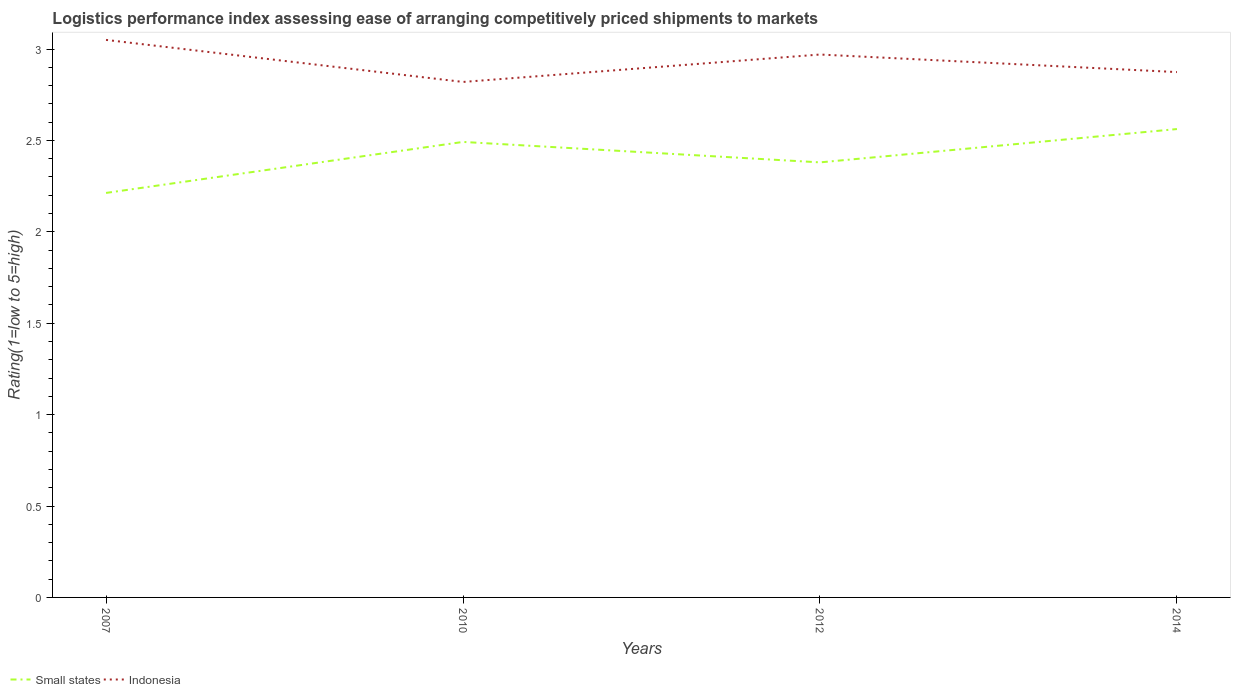How many different coloured lines are there?
Provide a succinct answer. 2. Does the line corresponding to Small states intersect with the line corresponding to Indonesia?
Keep it short and to the point. No. Is the number of lines equal to the number of legend labels?
Offer a very short reply. Yes. Across all years, what is the maximum Logistic performance index in Indonesia?
Keep it short and to the point. 2.82. In which year was the Logistic performance index in Indonesia maximum?
Give a very brief answer. 2010. What is the total Logistic performance index in Small states in the graph?
Make the answer very short. -0.28. What is the difference between the highest and the second highest Logistic performance index in Small states?
Your response must be concise. 0.35. What is the difference between two consecutive major ticks on the Y-axis?
Provide a short and direct response. 0.5. Are the values on the major ticks of Y-axis written in scientific E-notation?
Keep it short and to the point. No. What is the title of the graph?
Offer a very short reply. Logistics performance index assessing ease of arranging competitively priced shipments to markets. What is the label or title of the X-axis?
Offer a terse response. Years. What is the label or title of the Y-axis?
Offer a terse response. Rating(1=low to 5=high). What is the Rating(1=low to 5=high) of Small states in 2007?
Your answer should be very brief. 2.21. What is the Rating(1=low to 5=high) of Indonesia in 2007?
Offer a very short reply. 3.05. What is the Rating(1=low to 5=high) in Small states in 2010?
Your answer should be compact. 2.49. What is the Rating(1=low to 5=high) of Indonesia in 2010?
Offer a very short reply. 2.82. What is the Rating(1=low to 5=high) of Small states in 2012?
Offer a very short reply. 2.38. What is the Rating(1=low to 5=high) in Indonesia in 2012?
Offer a terse response. 2.97. What is the Rating(1=low to 5=high) in Small states in 2014?
Your response must be concise. 2.56. What is the Rating(1=low to 5=high) of Indonesia in 2014?
Your response must be concise. 2.87. Across all years, what is the maximum Rating(1=low to 5=high) of Small states?
Provide a succinct answer. 2.56. Across all years, what is the maximum Rating(1=low to 5=high) in Indonesia?
Offer a very short reply. 3.05. Across all years, what is the minimum Rating(1=low to 5=high) in Small states?
Ensure brevity in your answer.  2.21. Across all years, what is the minimum Rating(1=low to 5=high) of Indonesia?
Offer a very short reply. 2.82. What is the total Rating(1=low to 5=high) in Small states in the graph?
Provide a succinct answer. 9.65. What is the total Rating(1=low to 5=high) of Indonesia in the graph?
Make the answer very short. 11.71. What is the difference between the Rating(1=low to 5=high) of Small states in 2007 and that in 2010?
Give a very brief answer. -0.28. What is the difference between the Rating(1=low to 5=high) of Indonesia in 2007 and that in 2010?
Ensure brevity in your answer.  0.23. What is the difference between the Rating(1=low to 5=high) of Small states in 2007 and that in 2012?
Make the answer very short. -0.17. What is the difference between the Rating(1=low to 5=high) of Small states in 2007 and that in 2014?
Keep it short and to the point. -0.35. What is the difference between the Rating(1=low to 5=high) in Indonesia in 2007 and that in 2014?
Keep it short and to the point. 0.18. What is the difference between the Rating(1=low to 5=high) in Small states in 2010 and that in 2012?
Ensure brevity in your answer.  0.11. What is the difference between the Rating(1=low to 5=high) of Small states in 2010 and that in 2014?
Ensure brevity in your answer.  -0.07. What is the difference between the Rating(1=low to 5=high) of Indonesia in 2010 and that in 2014?
Your answer should be very brief. -0.05. What is the difference between the Rating(1=low to 5=high) in Small states in 2012 and that in 2014?
Provide a short and direct response. -0.18. What is the difference between the Rating(1=low to 5=high) in Indonesia in 2012 and that in 2014?
Offer a very short reply. 0.1. What is the difference between the Rating(1=low to 5=high) in Small states in 2007 and the Rating(1=low to 5=high) in Indonesia in 2010?
Offer a terse response. -0.61. What is the difference between the Rating(1=low to 5=high) of Small states in 2007 and the Rating(1=low to 5=high) of Indonesia in 2012?
Keep it short and to the point. -0.76. What is the difference between the Rating(1=low to 5=high) of Small states in 2007 and the Rating(1=low to 5=high) of Indonesia in 2014?
Your response must be concise. -0.66. What is the difference between the Rating(1=low to 5=high) of Small states in 2010 and the Rating(1=low to 5=high) of Indonesia in 2012?
Make the answer very short. -0.48. What is the difference between the Rating(1=low to 5=high) in Small states in 2010 and the Rating(1=low to 5=high) in Indonesia in 2014?
Ensure brevity in your answer.  -0.38. What is the difference between the Rating(1=low to 5=high) in Small states in 2012 and the Rating(1=low to 5=high) in Indonesia in 2014?
Your answer should be compact. -0.49. What is the average Rating(1=low to 5=high) in Small states per year?
Give a very brief answer. 2.41. What is the average Rating(1=low to 5=high) of Indonesia per year?
Give a very brief answer. 2.93. In the year 2007, what is the difference between the Rating(1=low to 5=high) in Small states and Rating(1=low to 5=high) in Indonesia?
Your answer should be very brief. -0.84. In the year 2010, what is the difference between the Rating(1=low to 5=high) in Small states and Rating(1=low to 5=high) in Indonesia?
Offer a terse response. -0.33. In the year 2012, what is the difference between the Rating(1=low to 5=high) in Small states and Rating(1=low to 5=high) in Indonesia?
Your response must be concise. -0.59. In the year 2014, what is the difference between the Rating(1=low to 5=high) of Small states and Rating(1=low to 5=high) of Indonesia?
Provide a short and direct response. -0.31. What is the ratio of the Rating(1=low to 5=high) in Small states in 2007 to that in 2010?
Your answer should be very brief. 0.89. What is the ratio of the Rating(1=low to 5=high) in Indonesia in 2007 to that in 2010?
Your answer should be very brief. 1.08. What is the ratio of the Rating(1=low to 5=high) of Small states in 2007 to that in 2012?
Your response must be concise. 0.93. What is the ratio of the Rating(1=low to 5=high) in Indonesia in 2007 to that in 2012?
Your answer should be compact. 1.03. What is the ratio of the Rating(1=low to 5=high) in Small states in 2007 to that in 2014?
Ensure brevity in your answer.  0.86. What is the ratio of the Rating(1=low to 5=high) in Indonesia in 2007 to that in 2014?
Your answer should be compact. 1.06. What is the ratio of the Rating(1=low to 5=high) of Small states in 2010 to that in 2012?
Provide a short and direct response. 1.05. What is the ratio of the Rating(1=low to 5=high) in Indonesia in 2010 to that in 2012?
Provide a short and direct response. 0.95. What is the ratio of the Rating(1=low to 5=high) of Small states in 2010 to that in 2014?
Provide a short and direct response. 0.97. What is the ratio of the Rating(1=low to 5=high) in Indonesia in 2010 to that in 2014?
Provide a short and direct response. 0.98. What is the ratio of the Rating(1=low to 5=high) of Small states in 2012 to that in 2014?
Offer a terse response. 0.93. What is the ratio of the Rating(1=low to 5=high) of Indonesia in 2012 to that in 2014?
Offer a terse response. 1.03. What is the difference between the highest and the second highest Rating(1=low to 5=high) of Small states?
Your answer should be compact. 0.07. What is the difference between the highest and the lowest Rating(1=low to 5=high) in Small states?
Your response must be concise. 0.35. What is the difference between the highest and the lowest Rating(1=low to 5=high) in Indonesia?
Offer a very short reply. 0.23. 